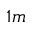<formula> <loc_0><loc_0><loc_500><loc_500>_ { 1 m }</formula> 